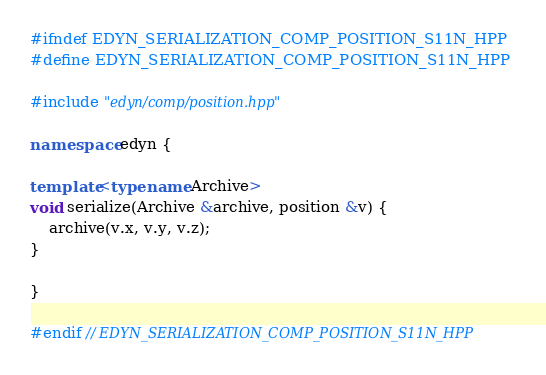Convert code to text. <code><loc_0><loc_0><loc_500><loc_500><_C++_>#ifndef EDYN_SERIALIZATION_COMP_POSITION_S11N_HPP
#define EDYN_SERIALIZATION_COMP_POSITION_S11N_HPP

#include "edyn/comp/position.hpp"

namespace edyn {

template<typename Archive>
void serialize(Archive &archive, position &v) {
    archive(v.x, v.y, v.z);
}

}

#endif // EDYN_SERIALIZATION_COMP_POSITION_S11N_HPP</code> 